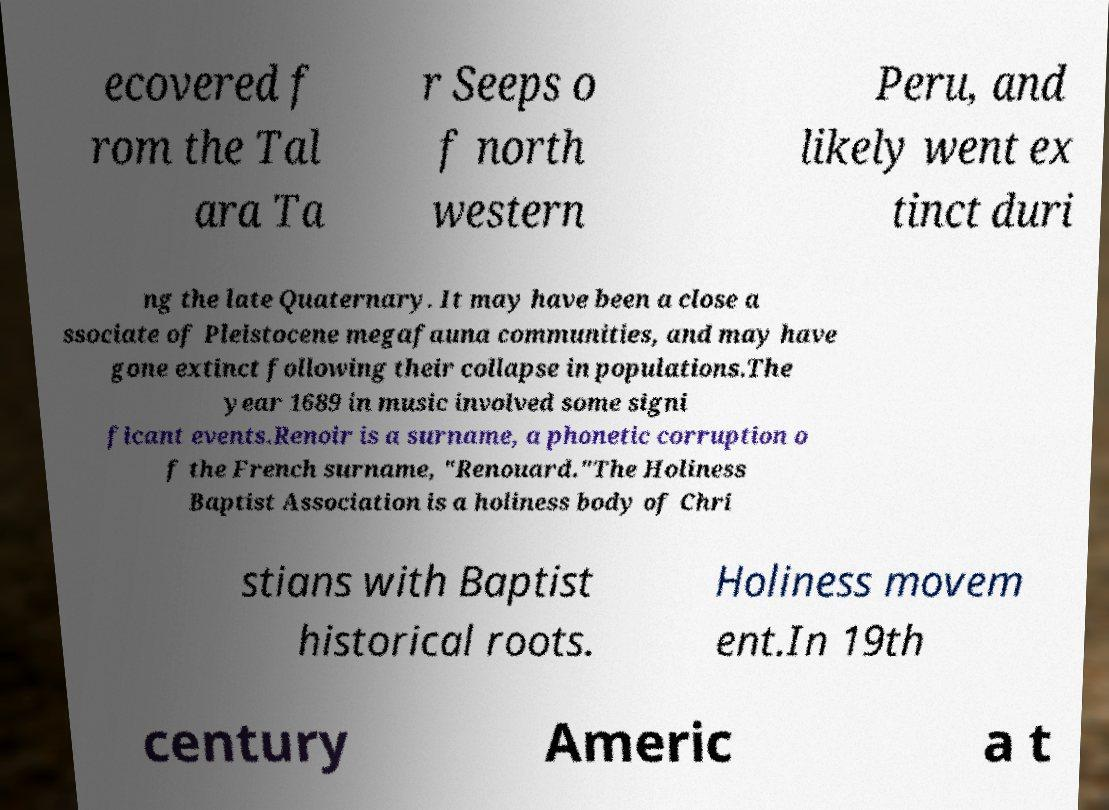What messages or text are displayed in this image? I need them in a readable, typed format. ecovered f rom the Tal ara Ta r Seeps o f north western Peru, and likely went ex tinct duri ng the late Quaternary. It may have been a close a ssociate of Pleistocene megafauna communities, and may have gone extinct following their collapse in populations.The year 1689 in music involved some signi ficant events.Renoir is a surname, a phonetic corruption o f the French surname, "Renouard."The Holiness Baptist Association is a holiness body of Chri stians with Baptist historical roots. Holiness movem ent.In 19th century Americ a t 